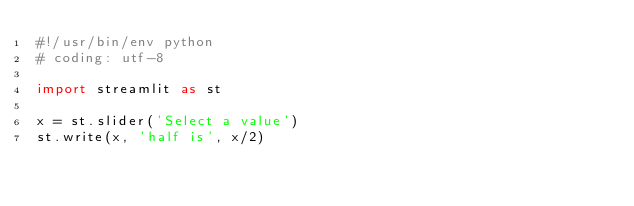<code> <loc_0><loc_0><loc_500><loc_500><_Python_>#!/usr/bin/env python
# coding: utf-8

import streamlit as st

x = st.slider('Select a value')
st.write(x, 'half is', x/2)


</code> 